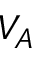Convert formula to latex. <formula><loc_0><loc_0><loc_500><loc_500>V _ { A }</formula> 